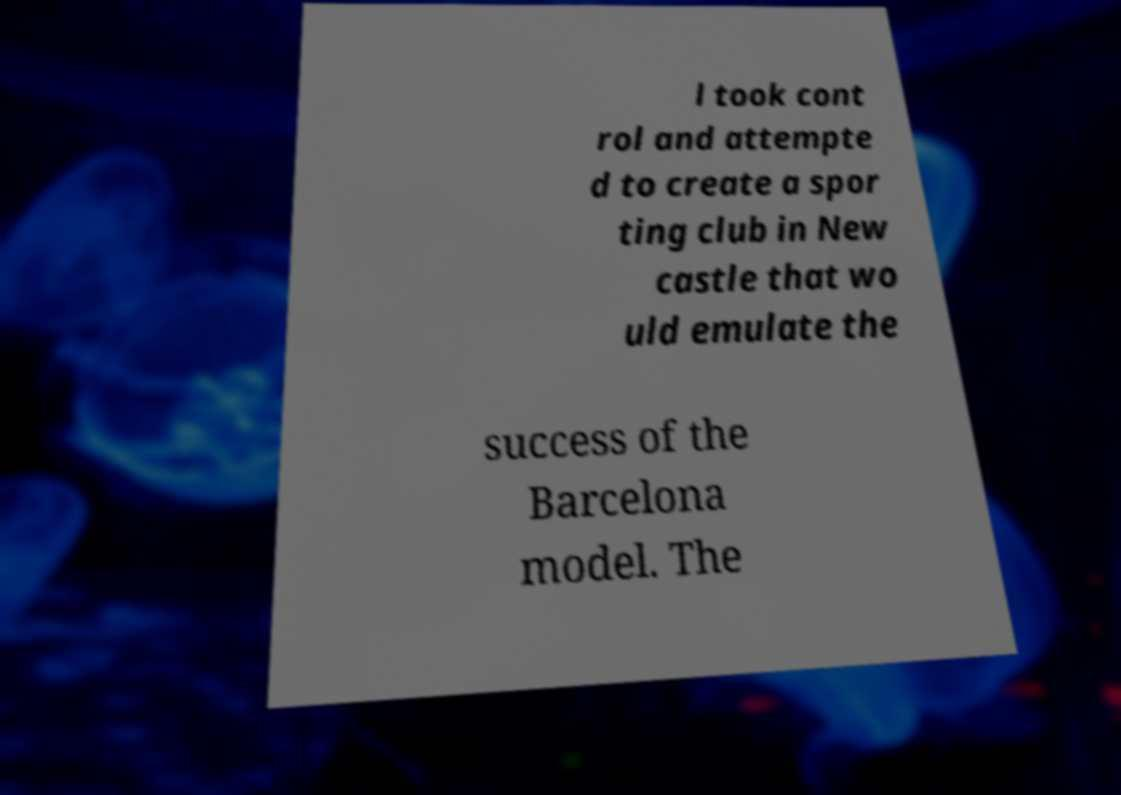Can you read and provide the text displayed in the image?This photo seems to have some interesting text. Can you extract and type it out for me? l took cont rol and attempte d to create a spor ting club in New castle that wo uld emulate the success of the Barcelona model. The 